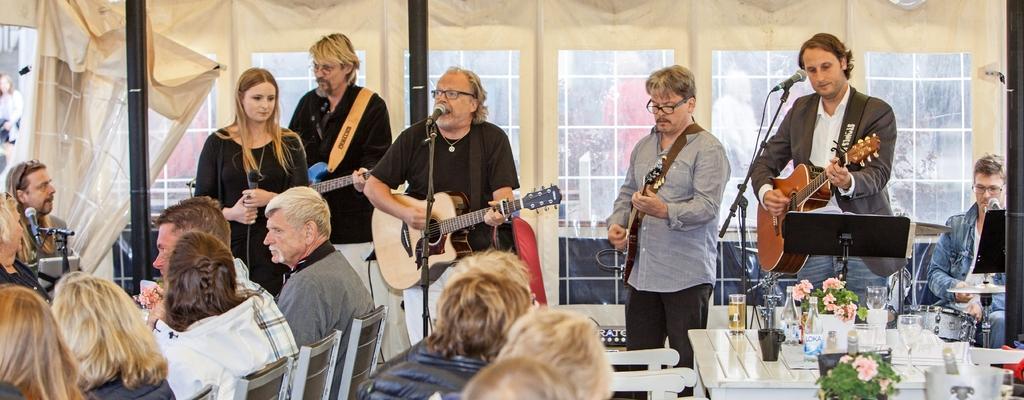Could you give a brief overview of what you see in this image? The picture consists of music band,the old man in the middle singing song and playing guitar and people on sides also playing guitar. There are few humans sat on chair in front of them. On the right side corner there is a table on which there are flower plants,glass,wine glasses. 